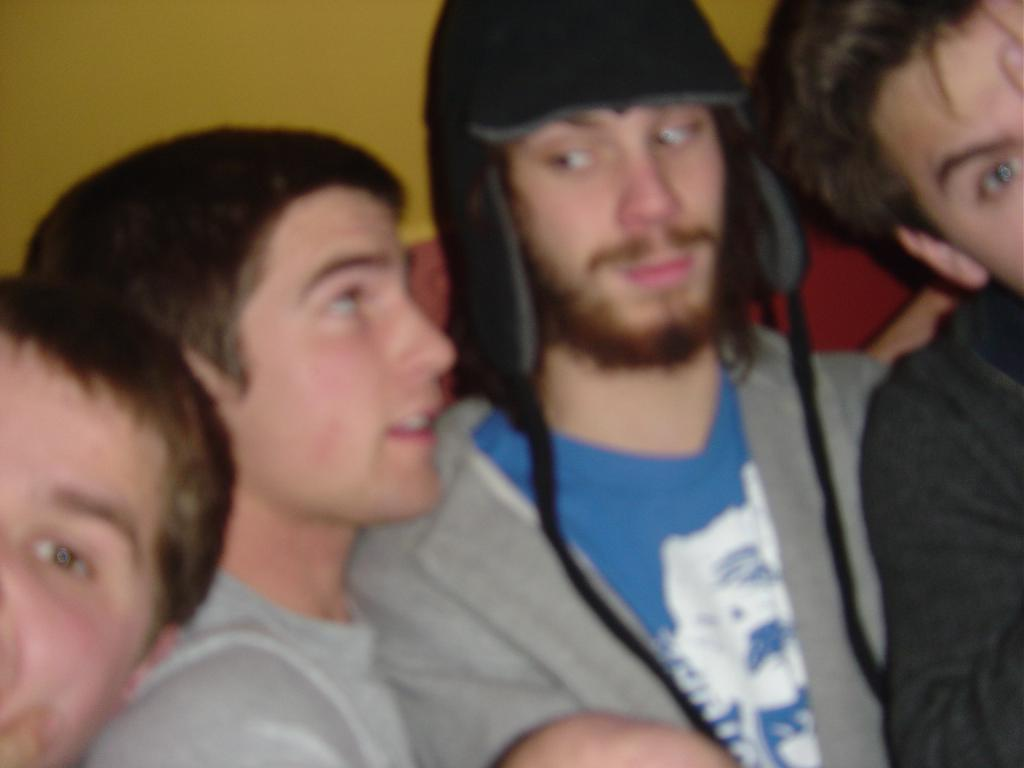What is the primary subject of the image? The primary subject of the image is the men. How are the middle two men interacting with each other? The middle two men are staring at each other. What direction are the corner men looking? The corner men are staring in the front. What is located behind the men in the image? There is a wall behind the men. What type of rock can be seen in the image? There is no rock present in the image; it features men and a wall. What is the texture of the men's clothing in the image? The provided facts do not mention the texture of the men's clothing, so it cannot be determined from the image. 